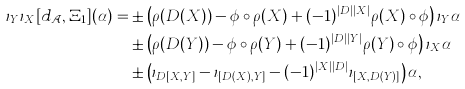<formula> <loc_0><loc_0><loc_500><loc_500>\iota _ { Y } \iota _ { X } [ d _ { \mathcal { A } } , \Xi _ { 1 } ] ( \alpha ) = & \pm \left ( \rho ( D ( X ) ) - \phi \circ \rho ( X ) + ( - 1 ) ^ { | D | | X | } \rho ( X ) \circ \phi \right ) \iota _ { Y } \alpha \\ & \pm \left ( \rho ( D ( Y ) ) - \phi \circ \rho ( Y ) + ( - 1 ) ^ { | D | | Y | } \rho ( Y ) \circ \phi \right ) \iota _ { X } \alpha \\ & \pm \left ( \iota _ { D [ X , Y ] } - \iota _ { [ D ( X ) , Y ] } - ( - 1 ) ^ { | X | | D | } \iota _ { [ X , D ( Y ) ] } \right ) \alpha ,</formula> 